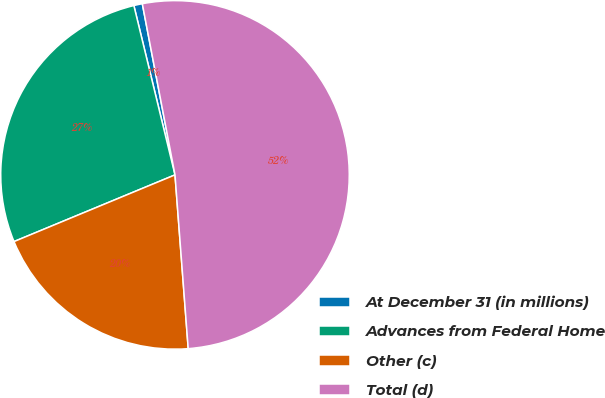<chart> <loc_0><loc_0><loc_500><loc_500><pie_chart><fcel>At December 31 (in millions)<fcel>Advances from Federal Home<fcel>Other (c)<fcel>Total (d)<nl><fcel>0.79%<fcel>27.46%<fcel>19.96%<fcel>51.8%<nl></chart> 